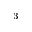<formula> <loc_0><loc_0><loc_500><loc_500>^ { - 3 }</formula> 